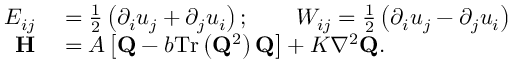Convert formula to latex. <formula><loc_0><loc_0><loc_500><loc_500>\begin{array} { r l } { E _ { i j } } & = \frac { 1 } { 2 } \left ( \partial _ { i } u _ { j } + \partial _ { j } u _ { i } \right ) ; \quad W _ { i j } = \frac { 1 } { 2 } \left ( \partial _ { i } u _ { j } - \partial _ { j } u _ { i } \right ) } \\ { H } & = A \left [ Q - b T r \left ( Q ^ { 2 } \right ) Q \right ] + K \nabla ^ { 2 } Q . } \end{array}</formula> 